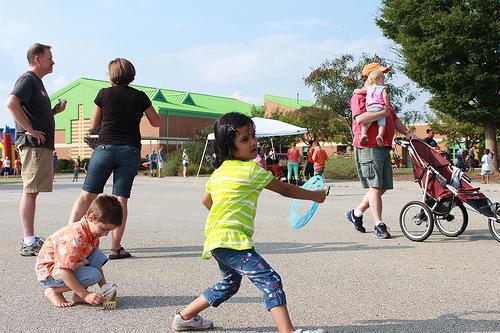How many people are wearing yellow and white shirts?
Give a very brief answer. 1. 